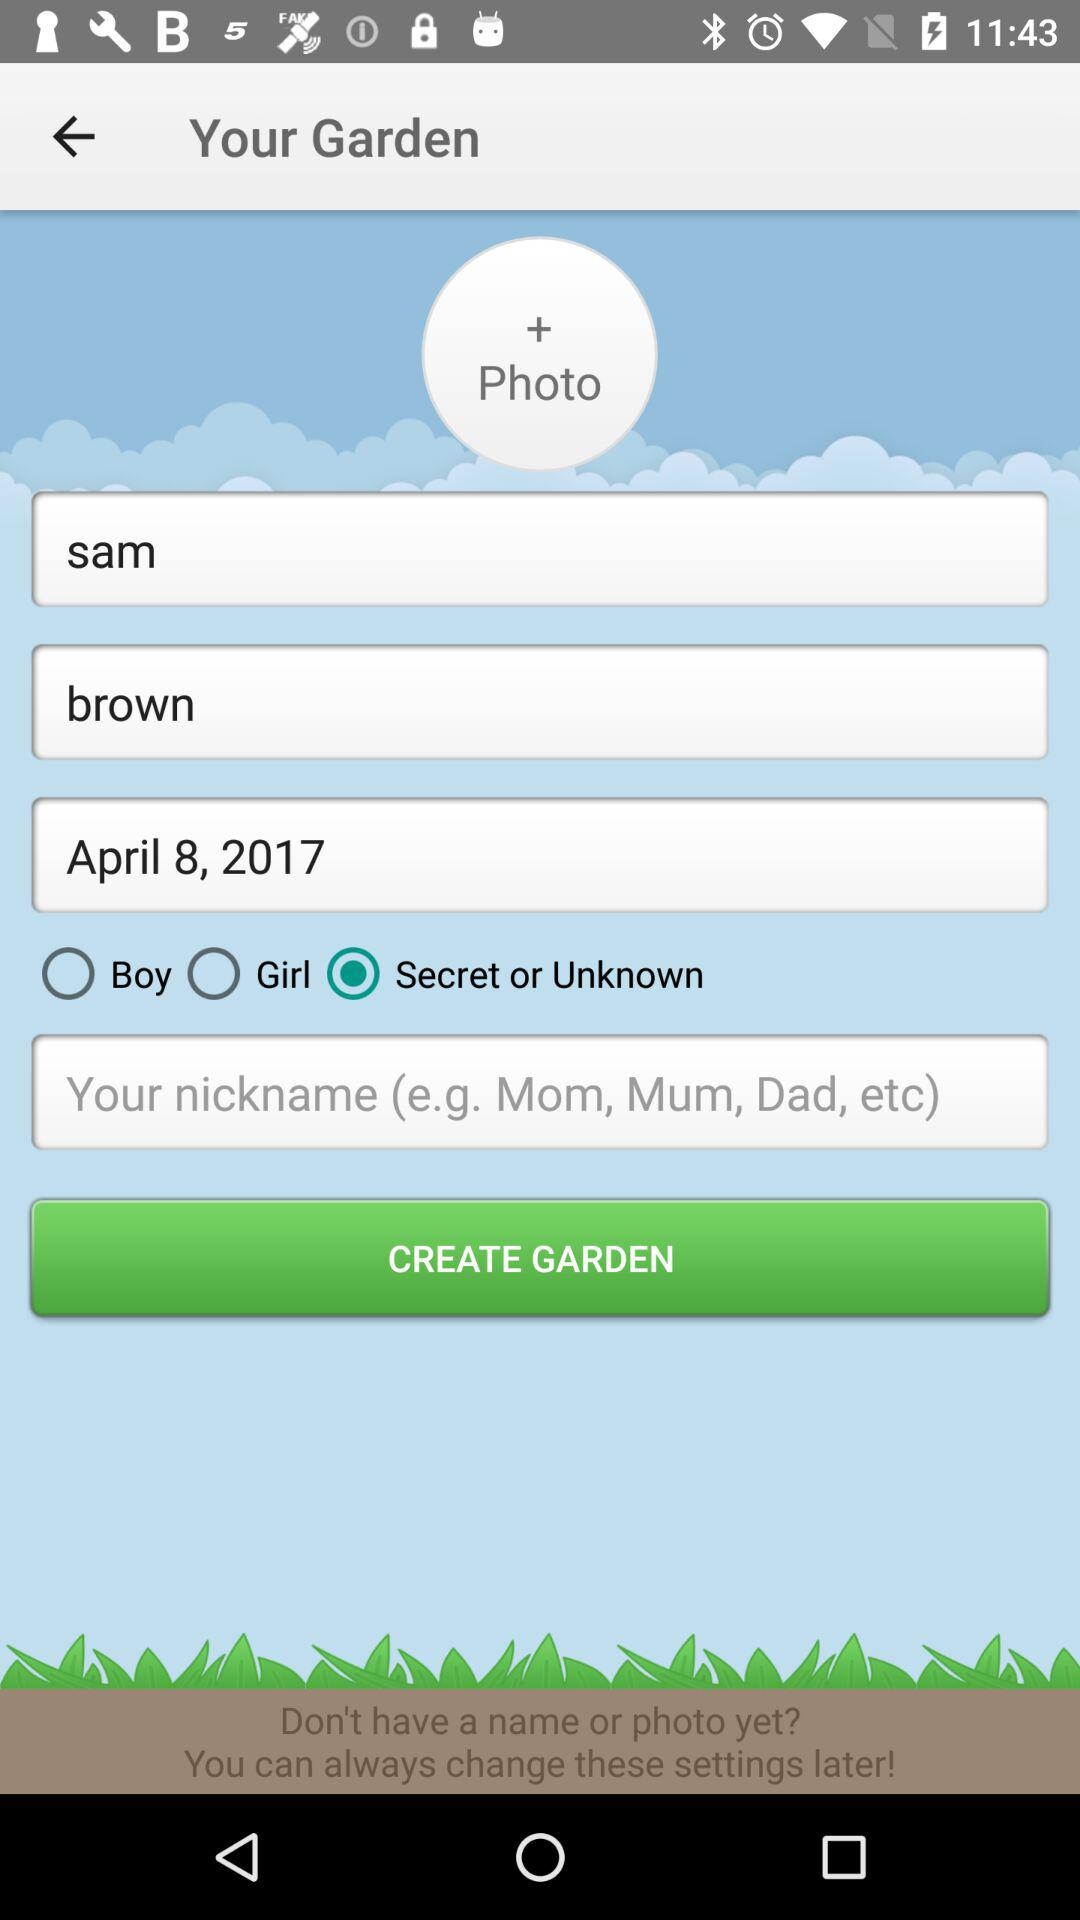What's the user name? The user name is Sam Brown. 